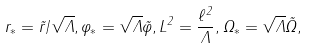<formula> <loc_0><loc_0><loc_500><loc_500>r _ { * } = \tilde { r } / \sqrt { \Lambda } , \varphi _ { * } = \sqrt { \Lambda } \tilde { \varphi } , L ^ { 2 } = \frac { \ell ^ { 2 } } { \Lambda } , \Omega _ { * } = \sqrt { \Lambda } \tilde { \Omega } ,</formula> 